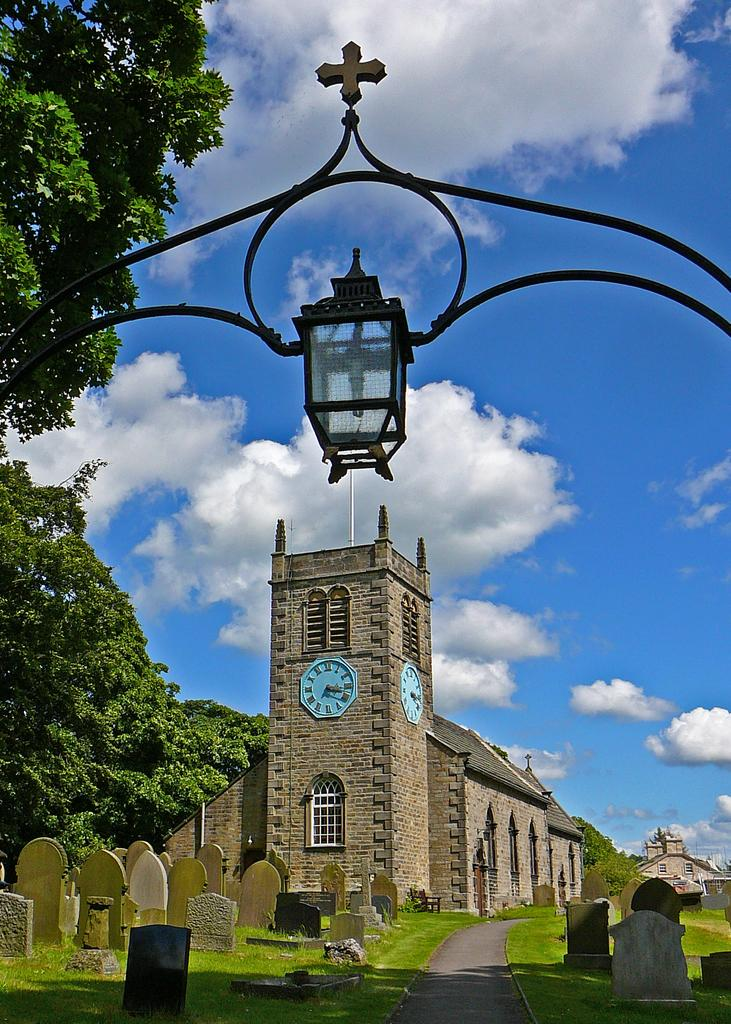What type of structures can be seen in the image? There are cemeteries and a house in the image. What features can be observed on the house? The house has two clocks and windows. What is the purpose of the lamp in the image? The lamp provides light. What type of vegetation is present in the image? There are trees in the image. How many children are playing with the worm in the image? There are no children or worms present in the image. What type of horse can be seen grazing near the house in the image? There is no horse present in the image; it only features cemeteries, a house, a lamp, and trees. 